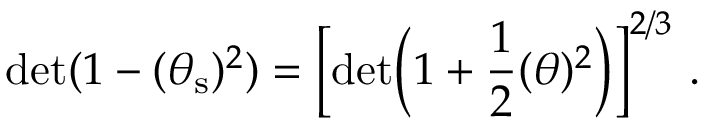Convert formula to latex. <formula><loc_0><loc_0><loc_500><loc_500>d e t ( 1 - ( \theta _ { s } ) ^ { 2 } ) = \left [ d e t \left ( 1 + \frac { 1 } { 2 } ( \theta ) ^ { 2 } \right ) \right ] ^ { 2 / 3 } \ .</formula> 